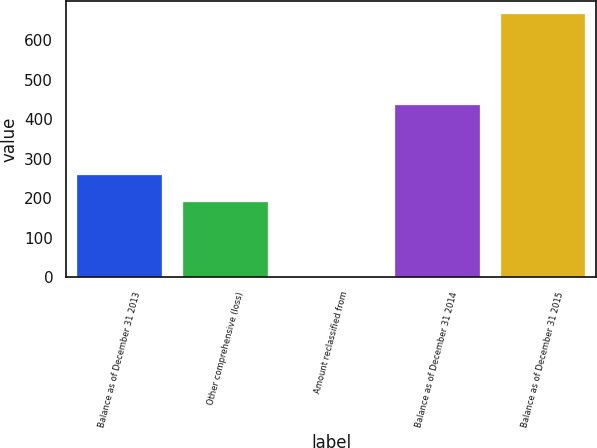<chart> <loc_0><loc_0><loc_500><loc_500><bar_chart><fcel>Balance as of December 31 2013<fcel>Other comprehensive (loss)<fcel>Amount reclassified from<fcel>Balance as of December 31 2014<fcel>Balance as of December 31 2015<nl><fcel>258.17<fcel>191.7<fcel>0.9<fcel>436.3<fcel>665.6<nl></chart> 